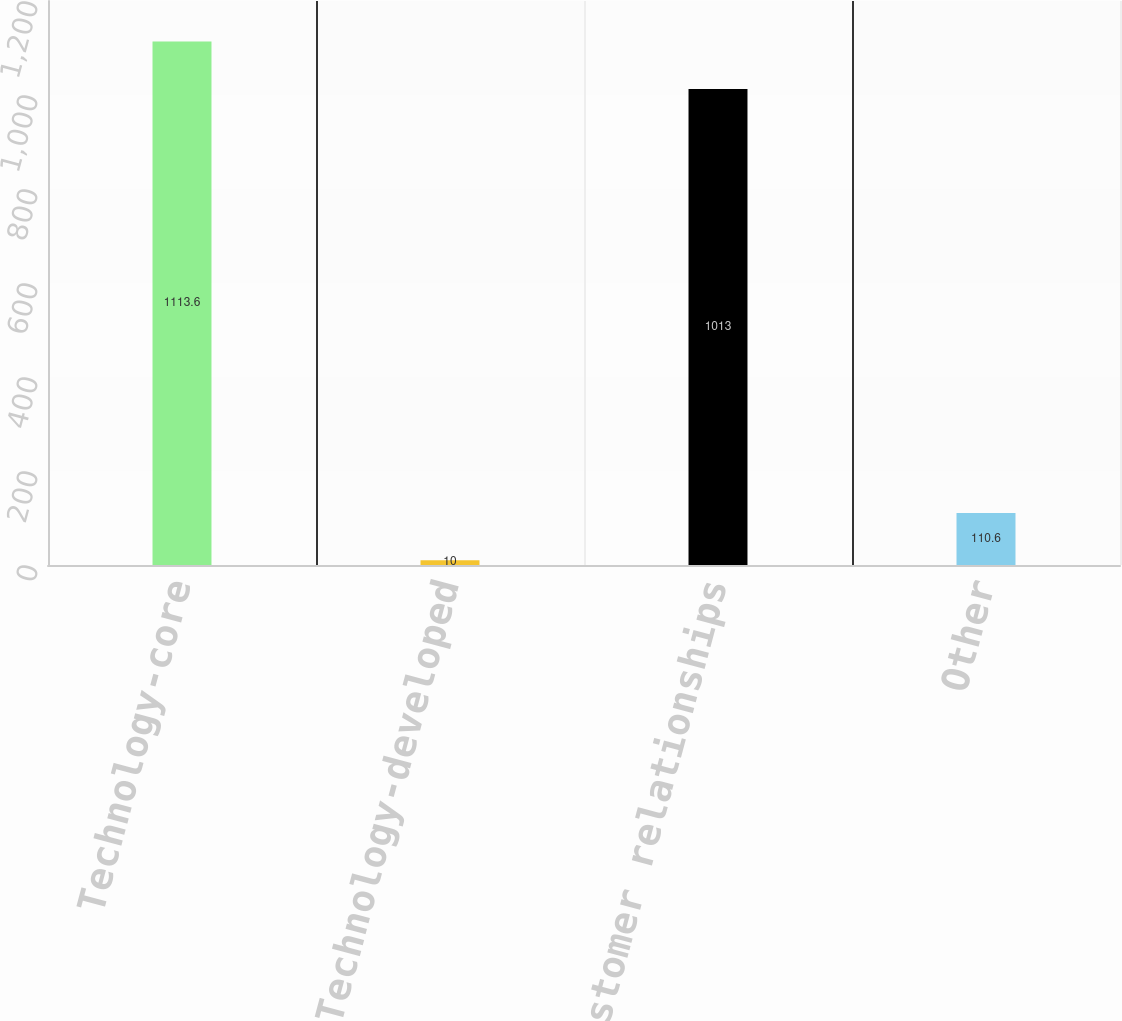Convert chart. <chart><loc_0><loc_0><loc_500><loc_500><bar_chart><fcel>Technology-core<fcel>Technology-developed<fcel>Customer relationships<fcel>Other<nl><fcel>1113.6<fcel>10<fcel>1013<fcel>110.6<nl></chart> 